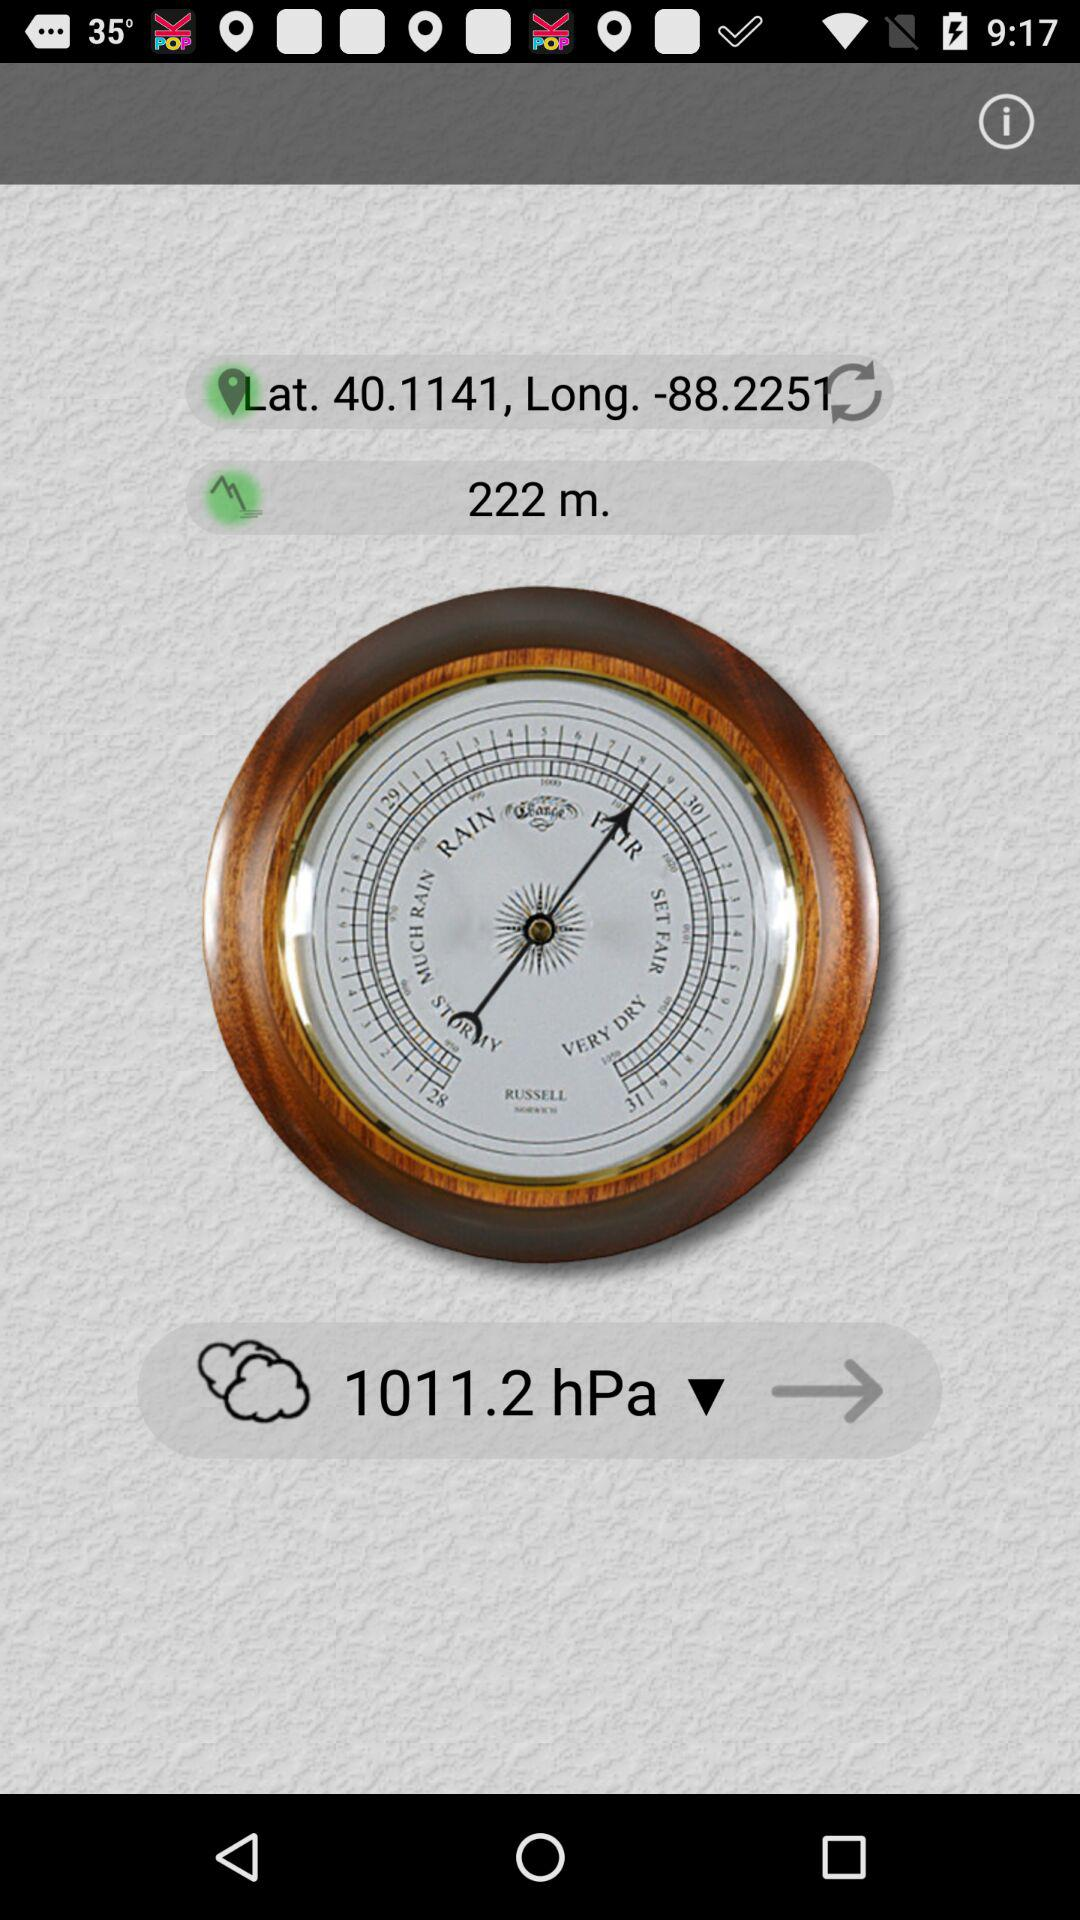What is the given distance? The given distance is 222 metres. 